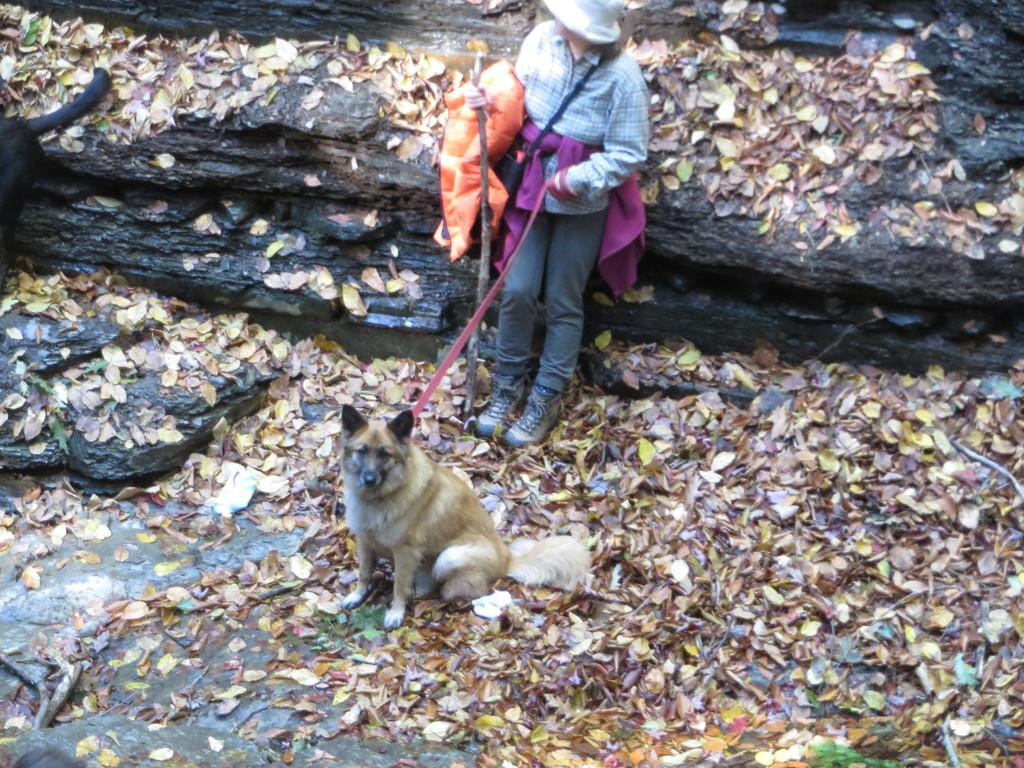What is the main subject of the image? There is a person standing in the image. What is the person holding in the image? The person is holding a stick. What animal is present in front of the person? There is a dog in front of the person. What can be seen at the bottom of the image? There are leaves at the bottom of the image. What type of headwear is the person wearing? The person is wearing a cap. What type of apparel is the dog wearing in the image? There is no apparel visible on the dog in the image. What detail can be seen on the stick that the person is holding? The provided facts do not mention any specific details about the stick. 